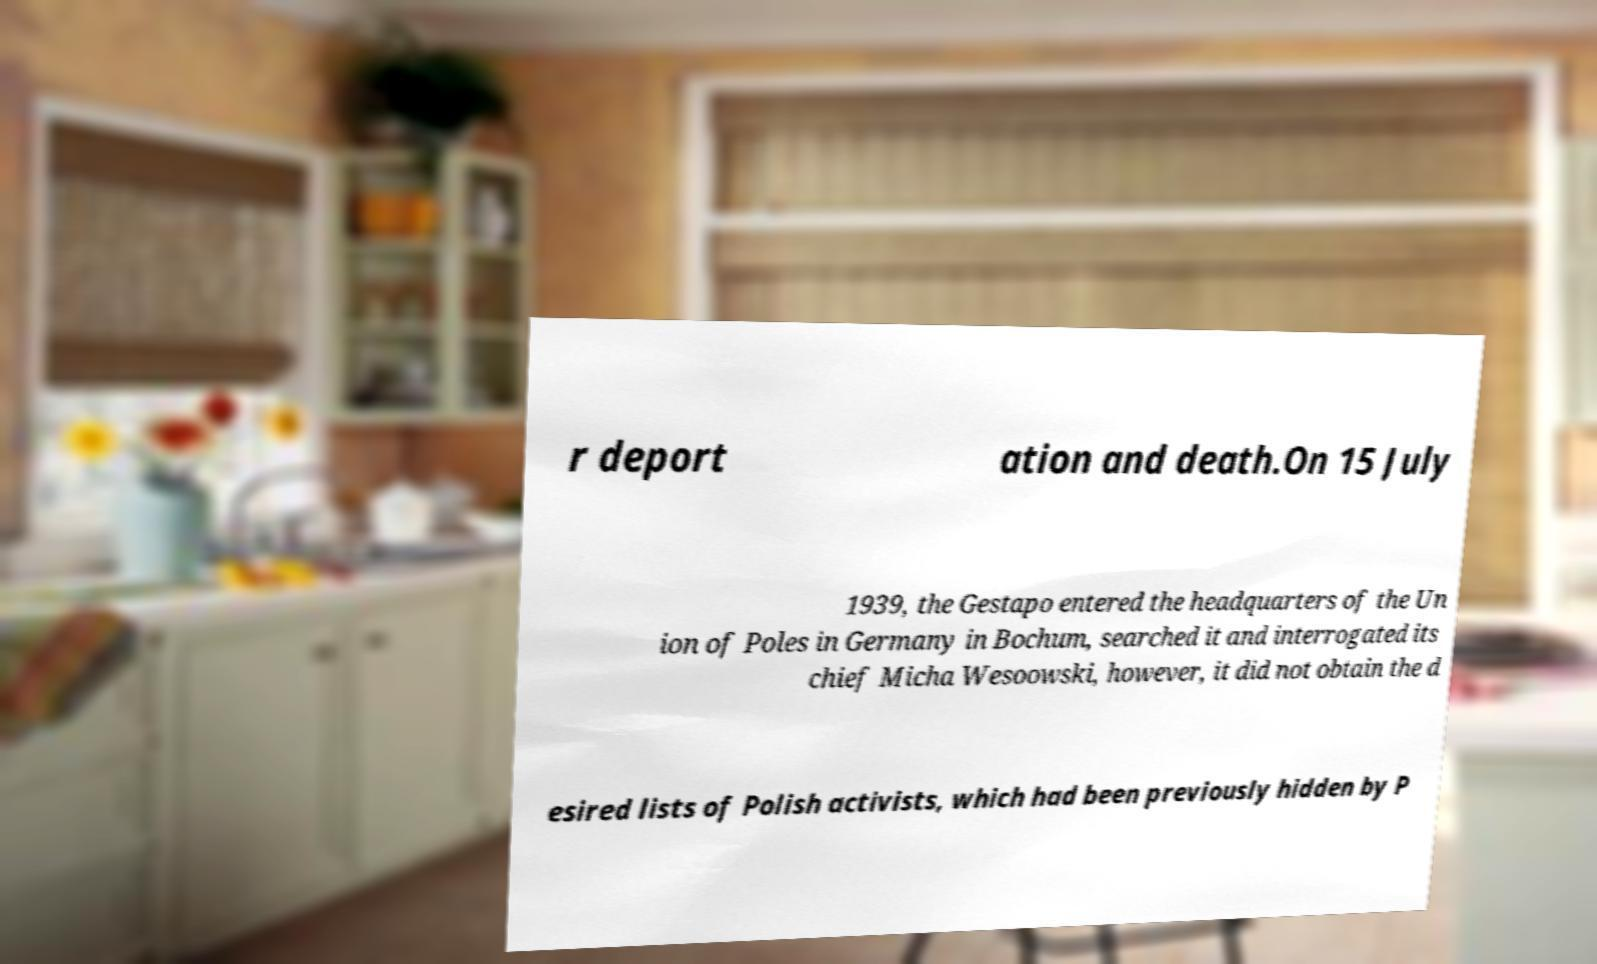Can you accurately transcribe the text from the provided image for me? r deport ation and death.On 15 July 1939, the Gestapo entered the headquarters of the Un ion of Poles in Germany in Bochum, searched it and interrogated its chief Micha Wesoowski, however, it did not obtain the d esired lists of Polish activists, which had been previously hidden by P 